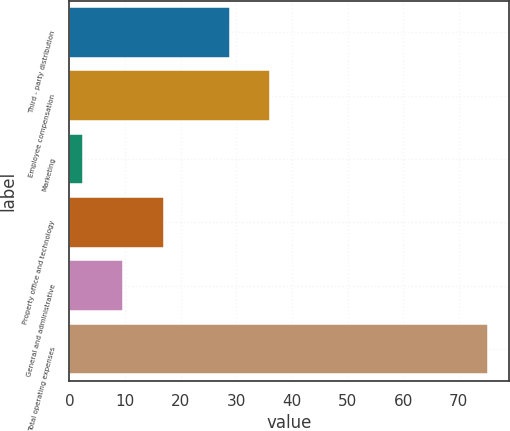<chart> <loc_0><loc_0><loc_500><loc_500><bar_chart><fcel>Third - party distribution<fcel>Employee compensation<fcel>Marketing<fcel>Property office and technology<fcel>General and administrative<fcel>Total operating expenses<nl><fcel>28.8<fcel>36.09<fcel>2.4<fcel>16.98<fcel>9.69<fcel>75.3<nl></chart> 